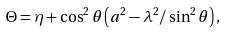Convert formula to latex. <formula><loc_0><loc_0><loc_500><loc_500>\Theta = \eta + \cos ^ { 2 } \theta \left ( a ^ { 2 } - \lambda ^ { 2 } / \sin ^ { 2 } \theta \right ) ,</formula> 